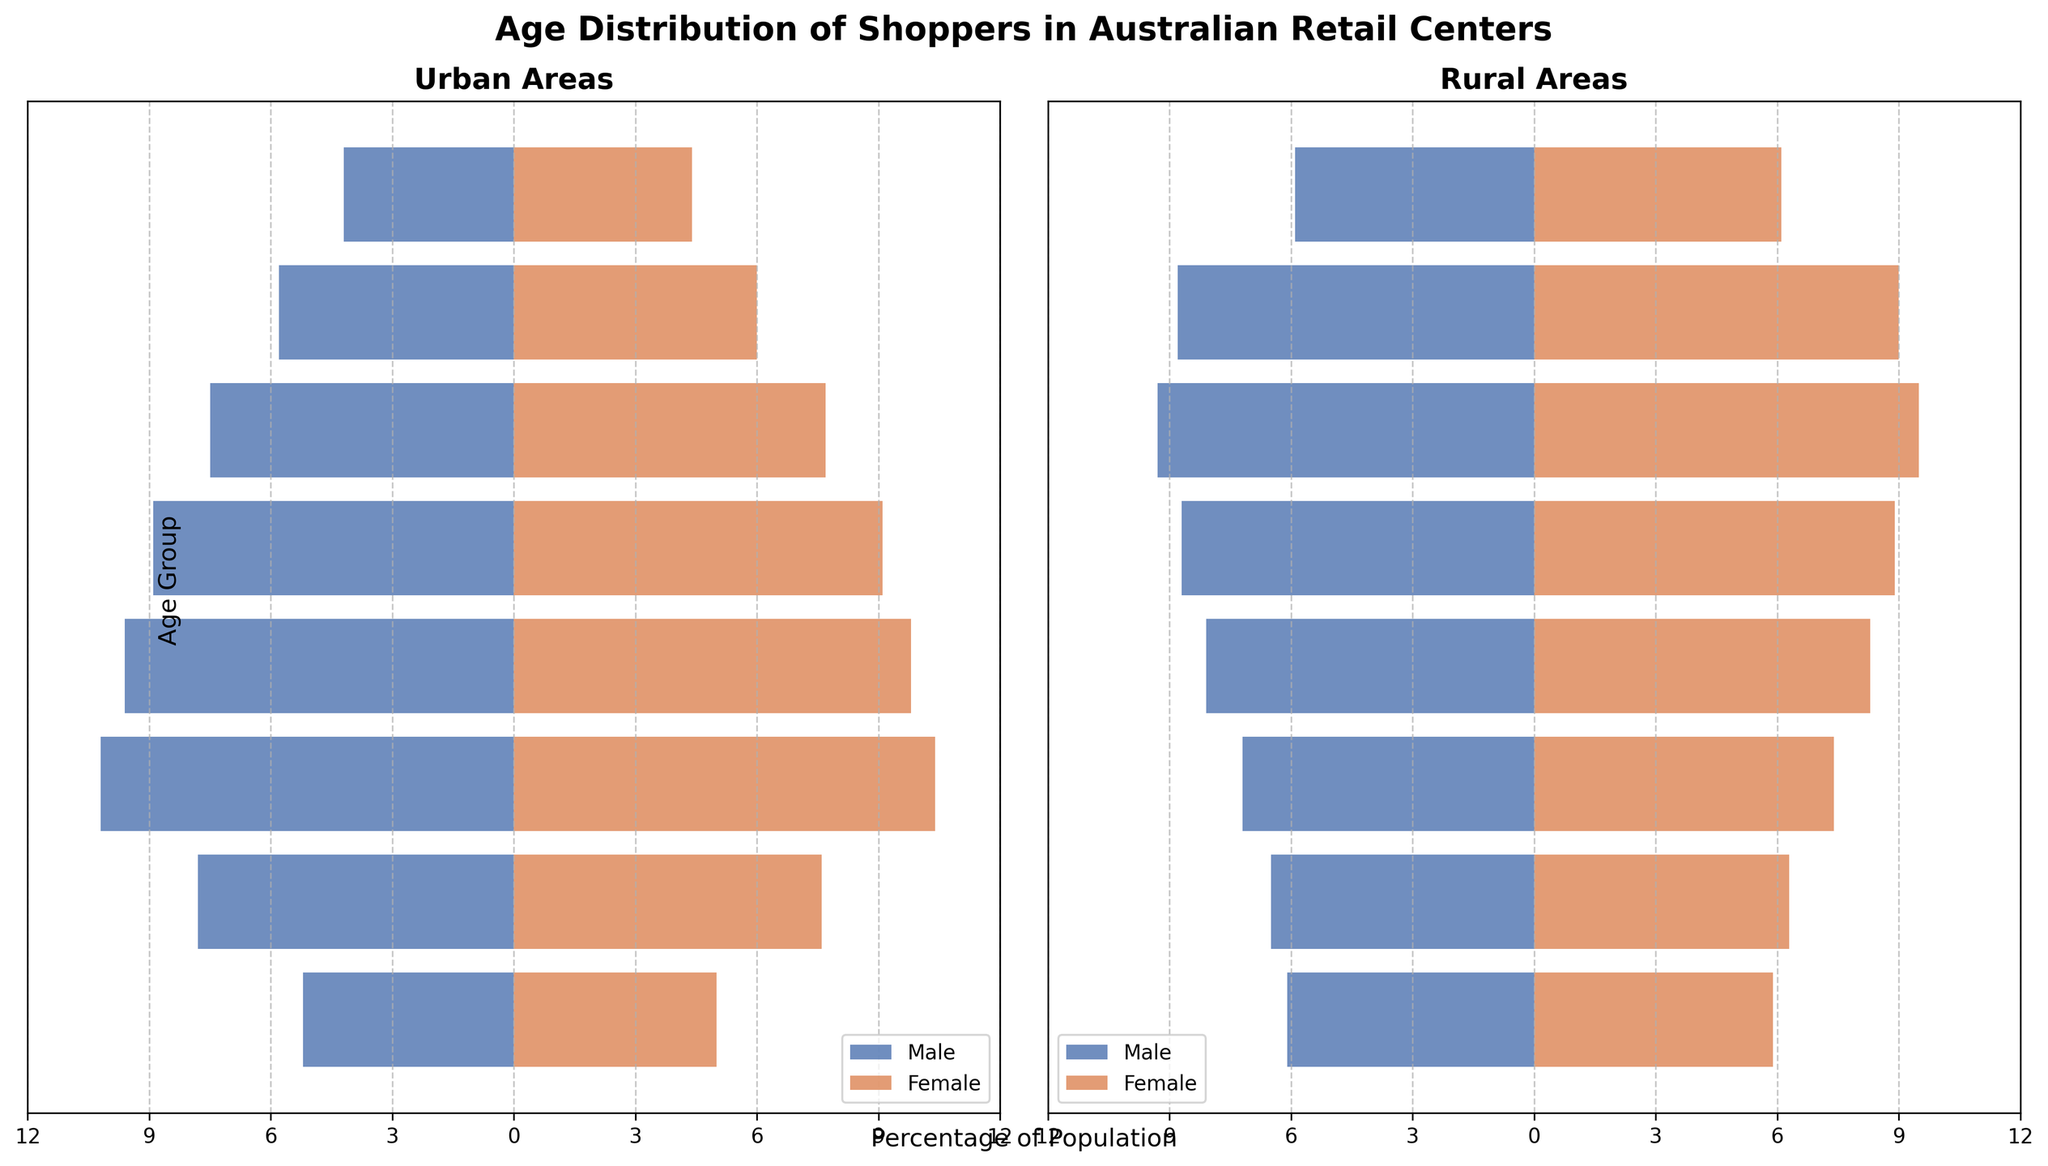What's the title of the figure? The title is usually at the top of the figure in bold text. The title provides a summary of what the data and chart represent. Here, it reads 'Age Distribution of Shoppers in Australian Retail Centers'.
Answer: Age Distribution of Shoppers in Australian Retail Centers What age group has the highest percentage of urban male shoppers? To find this, look at the horizontal bars representing urban male shoppers on the left side of the figure. The age group with the longest bar represents the highest percentage. The 25-34 age group has the longest bar for urban males.
Answer: 25-34 Compare the percentage of urban and rural female shoppers in the 55-64 age group. Look at the bars for the 55-64 age group on both urban and rural sides. The percentage for urban females is 7.7% and for rural females is 9.5%.
Answer: 7.7% (urban), 9.5% (rural) In which age group is there the smallest difference between the percentages of urban and rural male shoppers? Calculate the difference between urban male and rural male percentages for each age group and identify the smallest difference. The age group with the smallest difference is 45-54 (8.9% urban and 8.7% rural, difference is 0.2%).
Answer: 45-54 Which gender and age group combination has the lowest percentage of rural shoppers? Compare all the bars on the rural side of the figure. The combination with the shortest bar is rural male in the 0-14 age group with 6.1%.
Answer: Male, 0-14 Is there any age group where the percentage of rural female shoppers is less than rural male shoppers? Compare the bars of rural male and female for each age group to see if there's any instance where the female percentage is lower. For all age groups, the female percentage is equal to or higher than the male percentage.
Answer: No What can you infer about the age group 75+ in both urban and rural areas? Look at the bar lengths for the 75+ age group in both urban and rural areas for both genders. Urban areas have 4.2% male and 4.4% female, whereas rural areas have 5.9% male and 6.1% female. This indicates a higher percentage of elderly shoppers in rural areas.
Answer: Higher percentage in rural for both genders Which gender has the greatest difference in percentages between urban and rural areas in the 65-74 age group? Calculate the difference separately for males and females in the 65-74 age group. For males, it's 8.8% - 5.8% = 3.0%, and for females, it's 9.0% - 6.0% = 3.0%. Both genders have the same difference.
Answer: Both genders How do the percentages of urban and rural female shoppers compare in the 35-44 age group, and what does this infer? The urban female percentage in the 35-44 age group is 9.8%, and the rural female percentage is 8.3%. This suggests that there are relatively more female shoppers in urban areas than rural areas in this age group.
Answer: Urban higher, more female shoppers in urban areas Which age group has more rural shoppers than urban shoppers? To determine this, compare the percentages of all age groups for rural and urban categories. The age groups 55-64, 65-74, and 75+ have higher percentages of both genders in rural areas than urban areas.
Answer: 55-64, 65-74, 75+ 